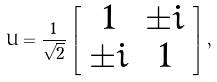Convert formula to latex. <formula><loc_0><loc_0><loc_500><loc_500>U = \frac { 1 } { \sqrt { 2 } } \left [ \begin{array} { c c } 1 & \pm i \\ \pm i & 1 \end{array} \right ] ,</formula> 